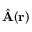<formula> <loc_0><loc_0><loc_500><loc_500>\hat { A } ( { r } )</formula> 